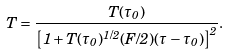Convert formula to latex. <formula><loc_0><loc_0><loc_500><loc_500>T = \frac { T ( \tau _ { 0 } ) } { \left [ 1 + T ( \tau _ { 0 } ) ^ { 1 / 2 } ( F / 2 ) ( \tau - \tau _ { 0 } ) \right ] ^ { 2 } } .</formula> 